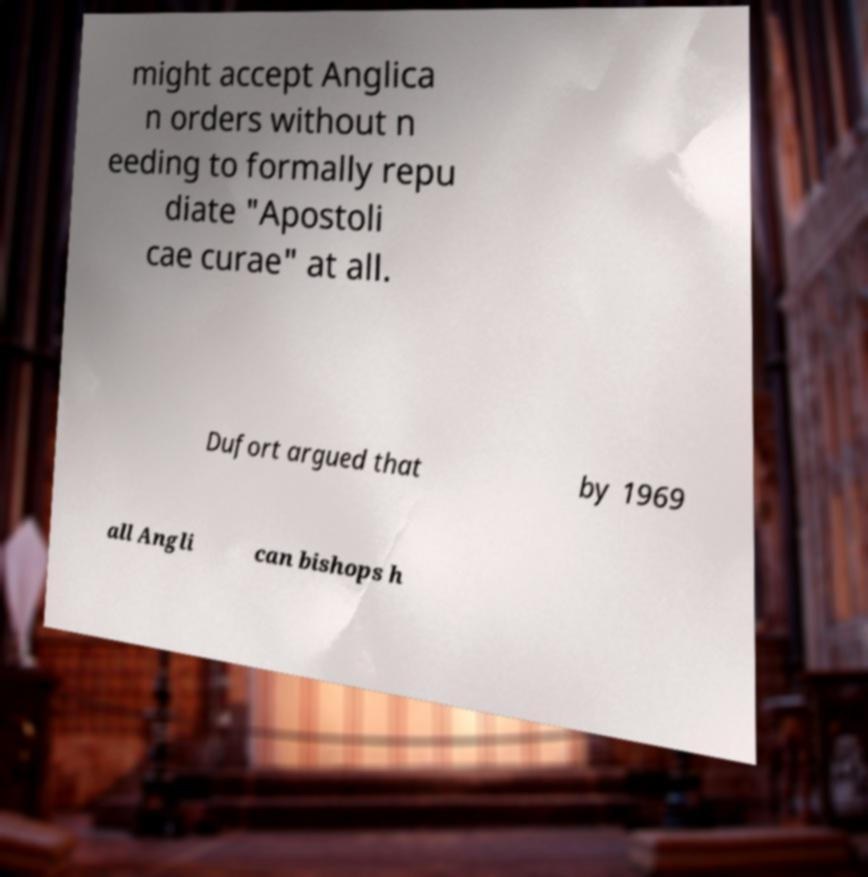Can you accurately transcribe the text from the provided image for me? might accept Anglica n orders without n eeding to formally repu diate "Apostoli cae curae" at all. Dufort argued that by 1969 all Angli can bishops h 